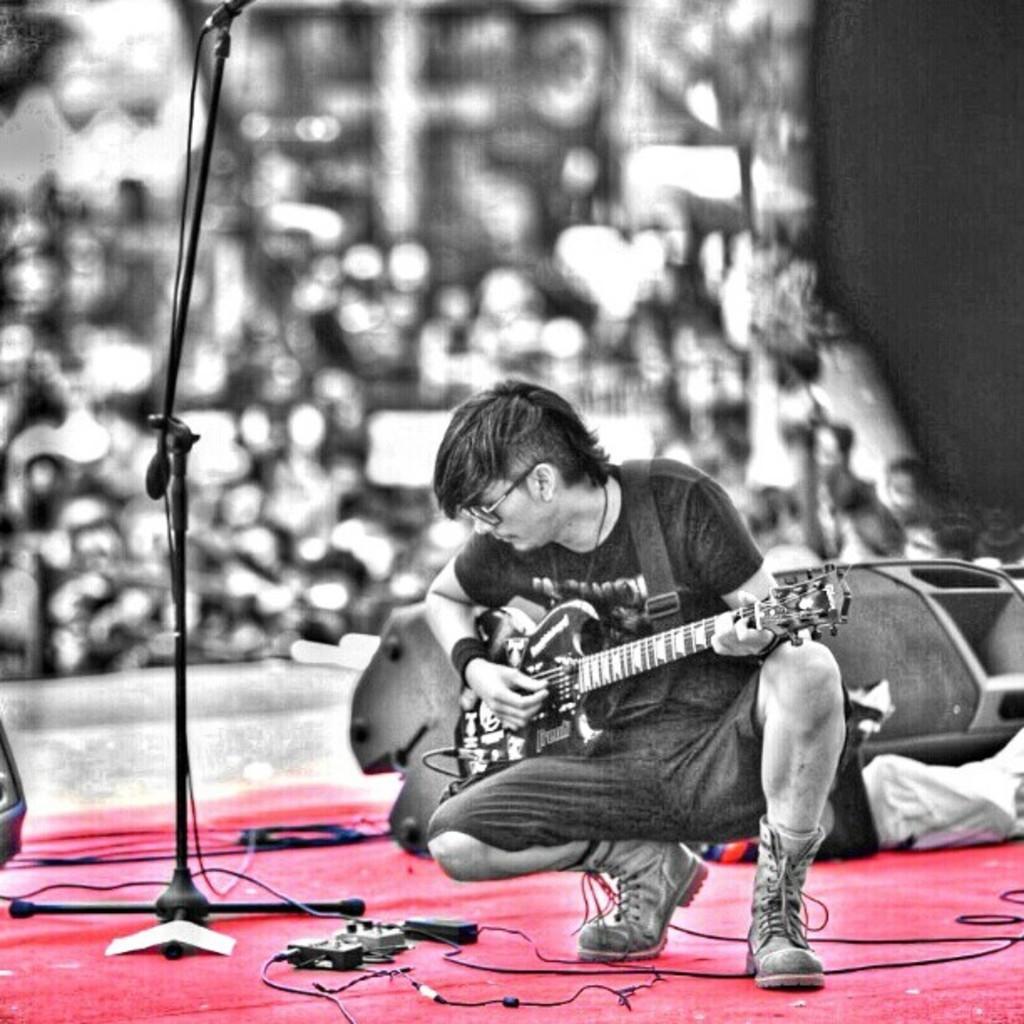In one or two sentences, can you explain what this image depicts? Here a man is playing guitar on the stage,beside him there is a microphone,behind him there are few people. 